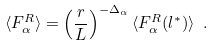Convert formula to latex. <formula><loc_0><loc_0><loc_500><loc_500>\langle F _ { \alpha } ^ { R } \rangle = \left ( \frac { r } { L } \right ) ^ { - \Delta _ { \alpha } } \langle F _ { \alpha } ^ { R } ( l ^ { * } ) \rangle \ .</formula> 